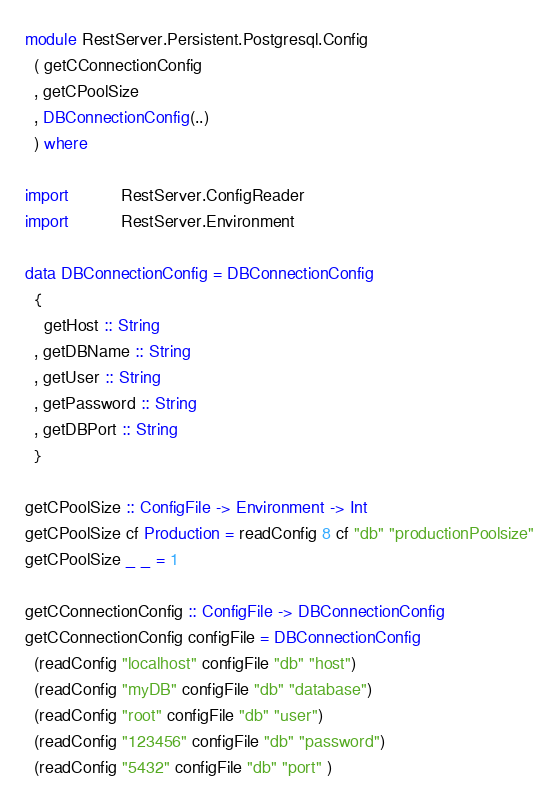Convert code to text. <code><loc_0><loc_0><loc_500><loc_500><_Haskell_>module RestServer.Persistent.Postgresql.Config
  ( getCConnectionConfig
  , getCPoolSize
  , DBConnectionConfig(..)
  ) where

import           RestServer.ConfigReader
import           RestServer.Environment

data DBConnectionConfig = DBConnectionConfig
  {
    getHost :: String
  , getDBName :: String
  , getUser :: String
  , getPassword :: String
  , getDBPort :: String
  }

getCPoolSize :: ConfigFile -> Environment -> Int
getCPoolSize cf Production = readConfig 8 cf "db" "productionPoolsize"
getCPoolSize _ _ = 1

getCConnectionConfig :: ConfigFile -> DBConnectionConfig
getCConnectionConfig configFile = DBConnectionConfig
  (readConfig "localhost" configFile "db" "host")
  (readConfig "myDB" configFile "db" "database")
  (readConfig "root" configFile "db" "user")
  (readConfig "123456" configFile "db" "password")
  (readConfig "5432" configFile "db" "port" )
</code> 